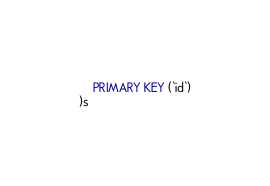<code> <loc_0><loc_0><loc_500><loc_500><_SQL_>	PRIMARY KEY (`id`)
)s</code> 